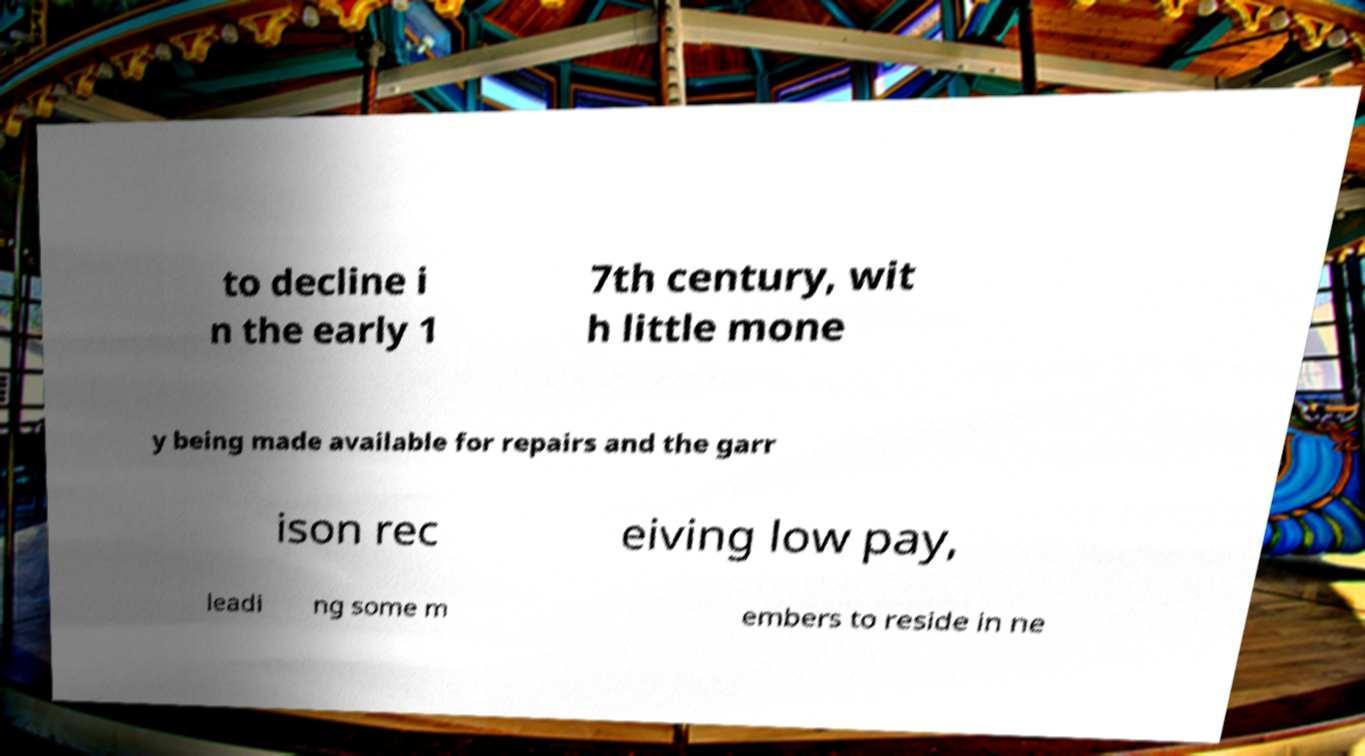I need the written content from this picture converted into text. Can you do that? to decline i n the early 1 7th century, wit h little mone y being made available for repairs and the garr ison rec eiving low pay, leadi ng some m embers to reside in ne 